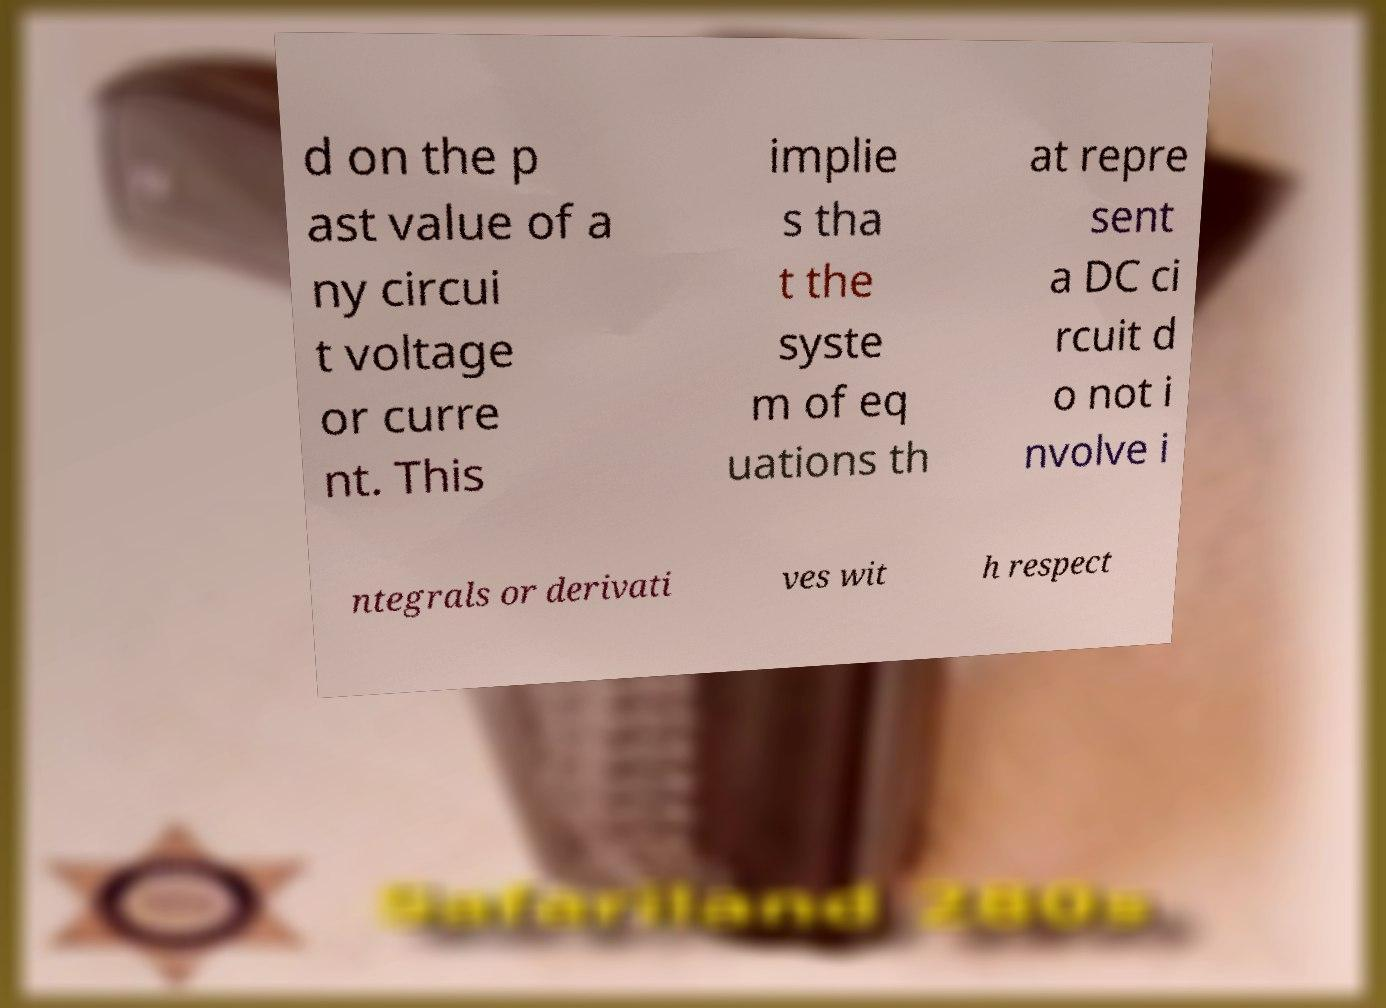Could you assist in decoding the text presented in this image and type it out clearly? d on the p ast value of a ny circui t voltage or curre nt. This implie s tha t the syste m of eq uations th at repre sent a DC ci rcuit d o not i nvolve i ntegrals or derivati ves wit h respect 